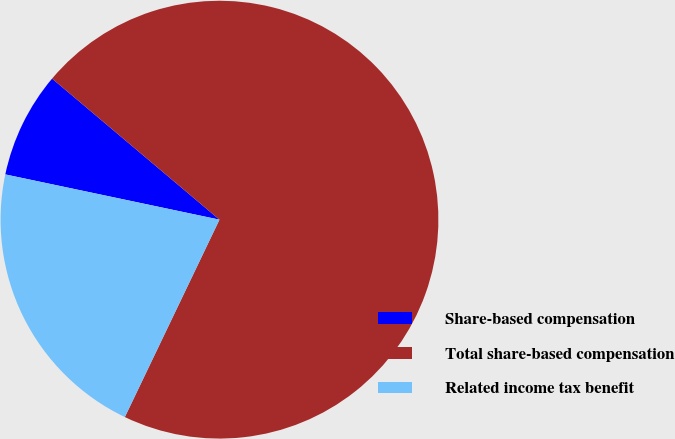Convert chart. <chart><loc_0><loc_0><loc_500><loc_500><pie_chart><fcel>Share-based compensation<fcel>Total share-based compensation<fcel>Related income tax benefit<nl><fcel>7.83%<fcel>70.97%<fcel>21.2%<nl></chart> 